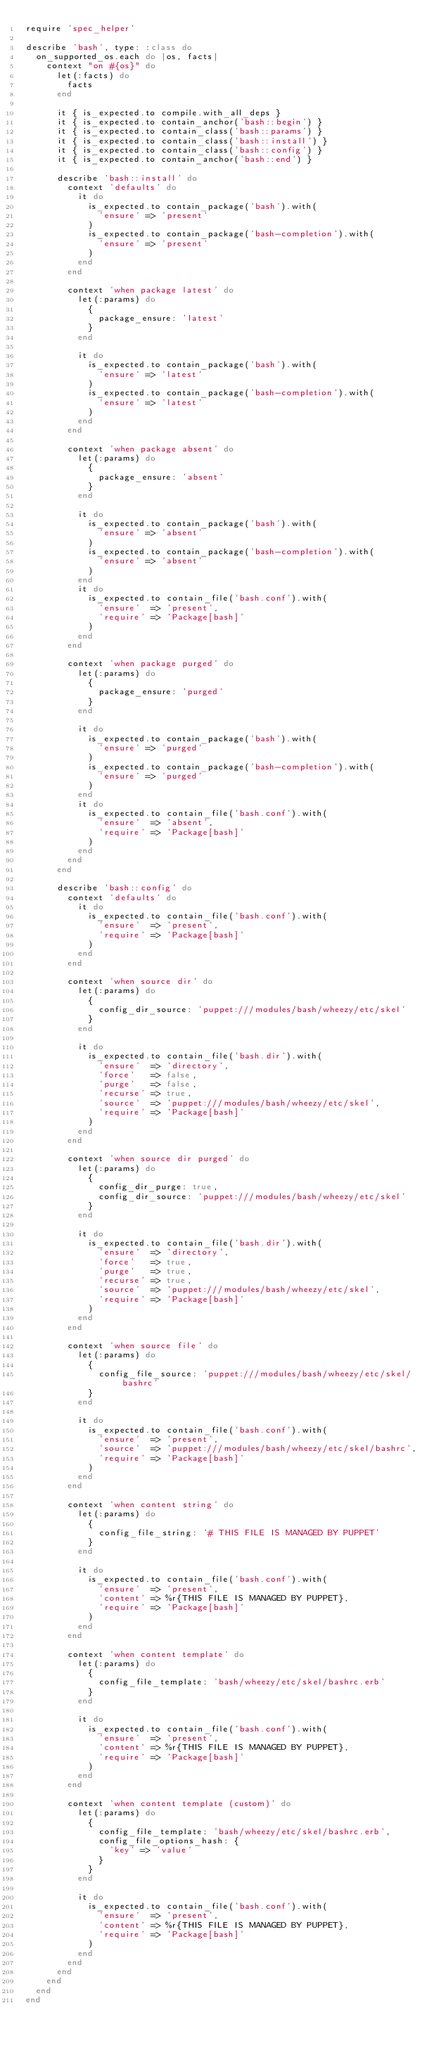<code> <loc_0><loc_0><loc_500><loc_500><_Ruby_>require 'spec_helper'

describe 'bash', type: :class do
  on_supported_os.each do |os, facts|
    context "on #{os}" do
      let(:facts) do
        facts
      end

      it { is_expected.to compile.with_all_deps }
      it { is_expected.to contain_anchor('bash::begin') }
      it { is_expected.to contain_class('bash::params') }
      it { is_expected.to contain_class('bash::install') }
      it { is_expected.to contain_class('bash::config') }
      it { is_expected.to contain_anchor('bash::end') }

      describe 'bash::install' do
        context 'defaults' do
          it do
            is_expected.to contain_package('bash').with(
              'ensure' => 'present'
            )
            is_expected.to contain_package('bash-completion').with(
              'ensure' => 'present'
            )
          end
        end

        context 'when package latest' do
          let(:params) do
            {
              package_ensure: 'latest'
            }
          end

          it do
            is_expected.to contain_package('bash').with(
              'ensure' => 'latest'
            )
            is_expected.to contain_package('bash-completion').with(
              'ensure' => 'latest'
            )
          end
        end

        context 'when package absent' do
          let(:params) do
            {
              package_ensure: 'absent'
            }
          end

          it do
            is_expected.to contain_package('bash').with(
              'ensure' => 'absent'
            )
            is_expected.to contain_package('bash-completion').with(
              'ensure' => 'absent'
            )
          end
          it do
            is_expected.to contain_file('bash.conf').with(
              'ensure'  => 'present',
              'require' => 'Package[bash]'
            )
          end
        end

        context 'when package purged' do
          let(:params) do
            {
              package_ensure: 'purged'
            }
          end

          it do
            is_expected.to contain_package('bash').with(
              'ensure' => 'purged'
            )
            is_expected.to contain_package('bash-completion').with(
              'ensure' => 'purged'
            )
          end
          it do
            is_expected.to contain_file('bash.conf').with(
              'ensure'  => 'absent',
              'require' => 'Package[bash]'
            )
          end
        end
      end

      describe 'bash::config' do
        context 'defaults' do
          it do
            is_expected.to contain_file('bash.conf').with(
              'ensure'  => 'present',
              'require' => 'Package[bash]'
            )
          end
        end

        context 'when source dir' do
          let(:params) do
            {
              config_dir_source: 'puppet:///modules/bash/wheezy/etc/skel'
            }
          end

          it do
            is_expected.to contain_file('bash.dir').with(
              'ensure'  => 'directory',
              'force'   => false,
              'purge'   => false,
              'recurse' => true,
              'source'  => 'puppet:///modules/bash/wheezy/etc/skel',
              'require' => 'Package[bash]'
            )
          end
        end

        context 'when source dir purged' do
          let(:params) do
            {
              config_dir_purge: true,
              config_dir_source: 'puppet:///modules/bash/wheezy/etc/skel'
            }
          end

          it do
            is_expected.to contain_file('bash.dir').with(
              'ensure'  => 'directory',
              'force'   => true,
              'purge'   => true,
              'recurse' => true,
              'source'  => 'puppet:///modules/bash/wheezy/etc/skel',
              'require' => 'Package[bash]'
            )
          end
        end

        context 'when source file' do
          let(:params) do
            {
              config_file_source: 'puppet:///modules/bash/wheezy/etc/skel/bashrc'
            }
          end

          it do
            is_expected.to contain_file('bash.conf').with(
              'ensure'  => 'present',
              'source'  => 'puppet:///modules/bash/wheezy/etc/skel/bashrc',
              'require' => 'Package[bash]'
            )
          end
        end

        context 'when content string' do
          let(:params) do
            {
              config_file_string: '# THIS FILE IS MANAGED BY PUPPET'
            }
          end

          it do
            is_expected.to contain_file('bash.conf').with(
              'ensure'  => 'present',
              'content' => %r{THIS FILE IS MANAGED BY PUPPET},
              'require' => 'Package[bash]'
            )
          end
        end

        context 'when content template' do
          let(:params) do
            {
              config_file_template: 'bash/wheezy/etc/skel/bashrc.erb'
            }
          end

          it do
            is_expected.to contain_file('bash.conf').with(
              'ensure'  => 'present',
              'content' => %r{THIS FILE IS MANAGED BY PUPPET},
              'require' => 'Package[bash]'
            )
          end
        end

        context 'when content template (custom)' do
          let(:params) do
            {
              config_file_template: 'bash/wheezy/etc/skel/bashrc.erb',
              config_file_options_hash: {
                'key' => 'value'
              }
            }
          end

          it do
            is_expected.to contain_file('bash.conf').with(
              'ensure'  => 'present',
              'content' => %r{THIS FILE IS MANAGED BY PUPPET},
              'require' => 'Package[bash]'
            )
          end
        end
      end
    end
  end
end
</code> 